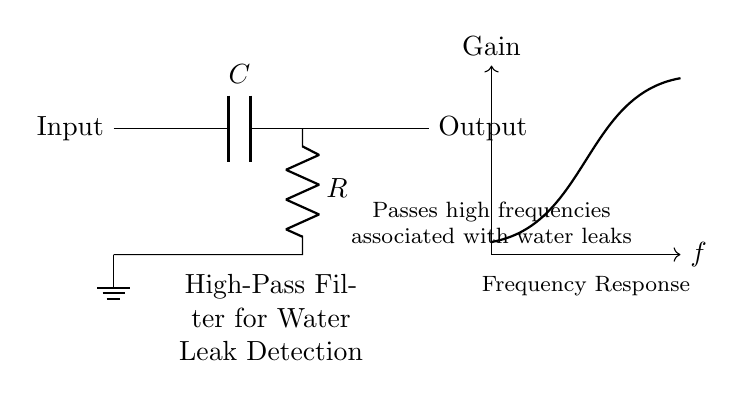What component is used to block low frequencies? The component used to block low frequencies in a high-pass filter is the capacitor. In the given circuit diagram, the capacitor is the first component in the signal path, which allows high frequencies to pass through while preventing low frequencies from being transmitted.
Answer: Capacitor What is the function of the resistor in this circuit? The resistor in this high-pass filter circuit determines the cutoff frequency along with the capacitor. It impedes the flow of current, which influences the overall response of the filter by defining how quickly the circuit can respond to changes in input frequencies.
Answer: Determining cutoff frequency Where is the output of the circuit taken from? The output of the circuit is taken from the point immediately after the resistor, where it connects to the output line of the circuit. This point effectively captures the filtered signal.
Answer: After the resistor What type of filter is represented in this circuit? The type of filter represented in this circuit is a high-pass filter. It is designed to allow frequencies above a certain cutoff frequency to pass while attenuating lower frequencies, making it suitable for detecting water leak characteristics.
Answer: High-pass filter What does the frequency response curve indicate? The frequency response curve indicates the relationship between frequency and gain in the circuit. It shows that as frequency increases beyond a certain point, the gain increases, which corresponds to the filtering behavior of the high-pass filter designed for detecting water leaks.
Answer: Relationship between frequency and gain At which point is ground established in the circuit? Ground is established at the bottom node of the circuit, connecting to the circuit's ground reference. This serves as a common return path for the current flowing through the components and ensures proper functioning of the circuit.
Answer: Bottom node 